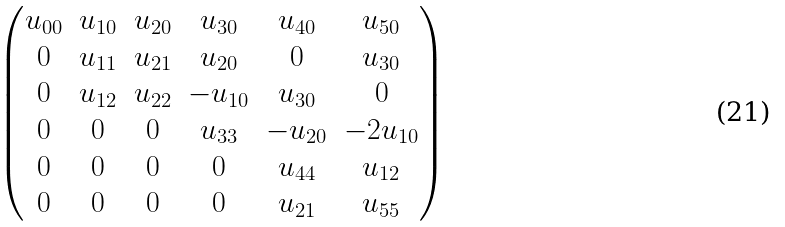<formula> <loc_0><loc_0><loc_500><loc_500>\begin{pmatrix} u _ { 0 0 } & u _ { 1 0 } & u _ { 2 0 } & u _ { 3 0 } & u _ { 4 0 } & u _ { 5 0 } \\ 0 & u _ { 1 1 } & u _ { 2 1 } & u _ { 2 0 } & 0 & u _ { 3 0 } \\ 0 & u _ { 1 2 } & u _ { 2 2 } & - u _ { 1 0 } & u _ { 3 0 } & 0 \\ 0 & 0 & 0 & u _ { 3 3 } & - u _ { 2 0 } & - 2 u _ { 1 0 } \\ 0 & 0 & 0 & 0 & u _ { 4 4 } & u _ { 1 2 } \\ 0 & 0 & 0 & 0 & u _ { 2 1 } & u _ { 5 5 } \end{pmatrix}</formula> 